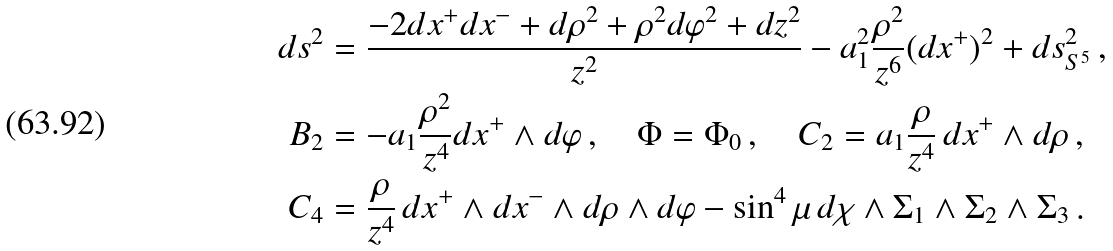<formula> <loc_0><loc_0><loc_500><loc_500>d s ^ { 2 } & = \frac { - 2 d x ^ { + } d x ^ { - } + d \rho ^ { 2 } + \rho ^ { 2 } d \varphi ^ { 2 } + d z ^ { 2 } } { z ^ { 2 } } - a _ { 1 } ^ { 2 } \frac { \rho ^ { 2 } } { z ^ { 6 } } ( d x ^ { + } ) ^ { 2 } + d s ^ { 2 } _ { S ^ { 5 } } \, , \\ B _ { 2 } & = - a _ { 1 } \frac { \rho ^ { 2 } } { z ^ { 4 } } d x ^ { + } \wedge d \varphi \, , \quad \Phi = \Phi _ { 0 } \, , \quad C _ { 2 } = a _ { 1 } \frac { \rho } { z ^ { 4 } } \, d x ^ { + } \wedge d \rho \, , \\ C _ { 4 } & = \frac { \rho } { z ^ { 4 } } \, d x ^ { + } \wedge d x ^ { - } \wedge d \rho \wedge d \varphi - \sin ^ { 4 } \mu \, d \chi \wedge \Sigma _ { 1 } \wedge \Sigma _ { 2 } \wedge \Sigma _ { 3 } \, .</formula> 